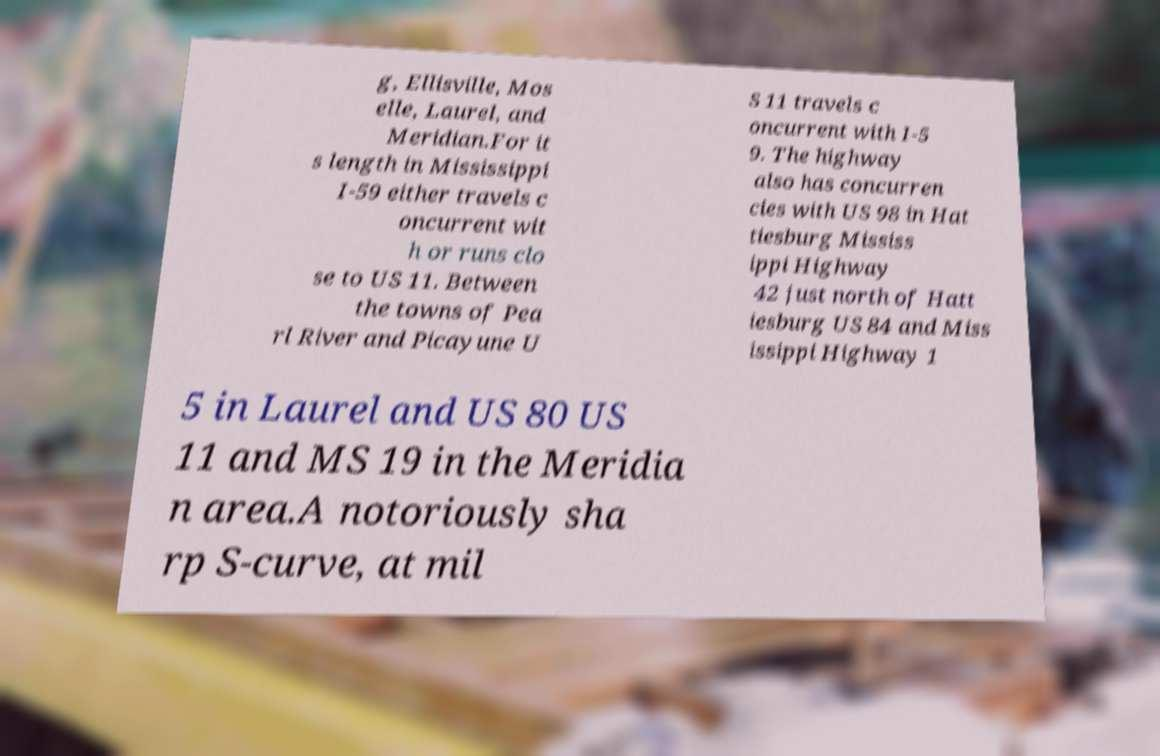What messages or text are displayed in this image? I need them in a readable, typed format. g, Ellisville, Mos elle, Laurel, and Meridian.For it s length in Mississippi I-59 either travels c oncurrent wit h or runs clo se to US 11. Between the towns of Pea rl River and Picayune U S 11 travels c oncurrent with I-5 9. The highway also has concurren cies with US 98 in Hat tiesburg Mississ ippi Highway 42 just north of Hatt iesburg US 84 and Miss issippi Highway 1 5 in Laurel and US 80 US 11 and MS 19 in the Meridia n area.A notoriously sha rp S-curve, at mil 